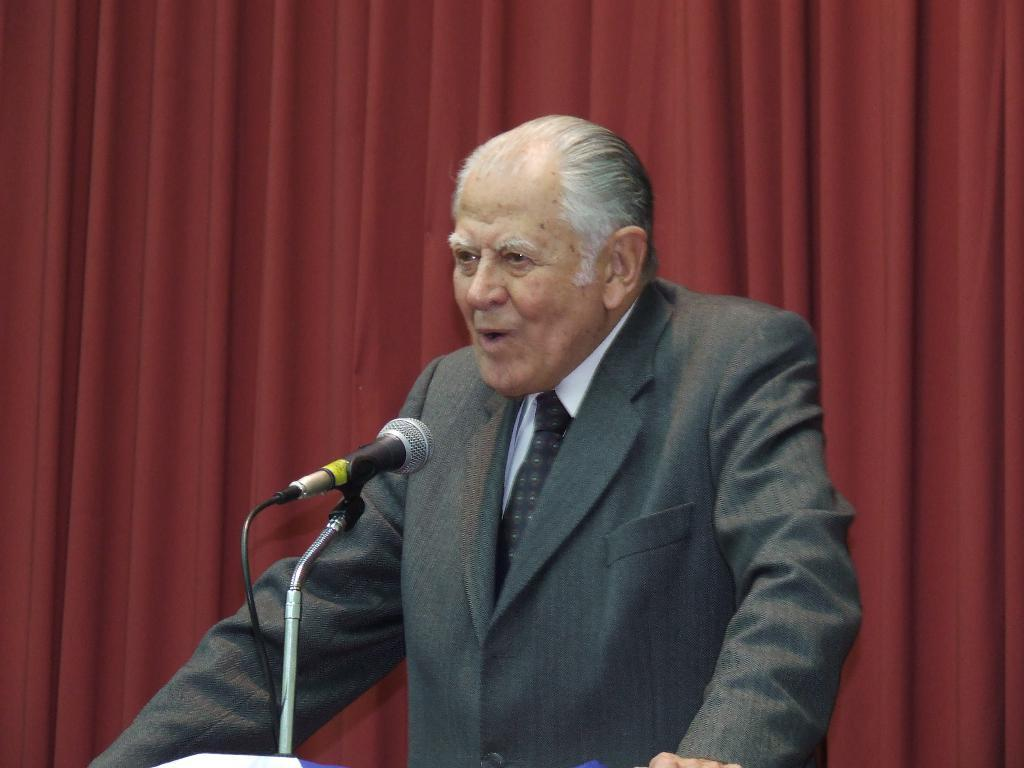Who is the main subject in the image? There is a man in the image. What is the man doing in the image? The man is standing at a podium and speaking with the help of a microphone. What is visible behind the man in the image? There is a curtain visible on the back. What type of ink is the man using to write on the podium? The man is not using any ink to write on the podium; he is speaking into a microphone. What rhythm is the man following while speaking in the image? There is no indication of a specific rhythm in the man's speech in the image. 